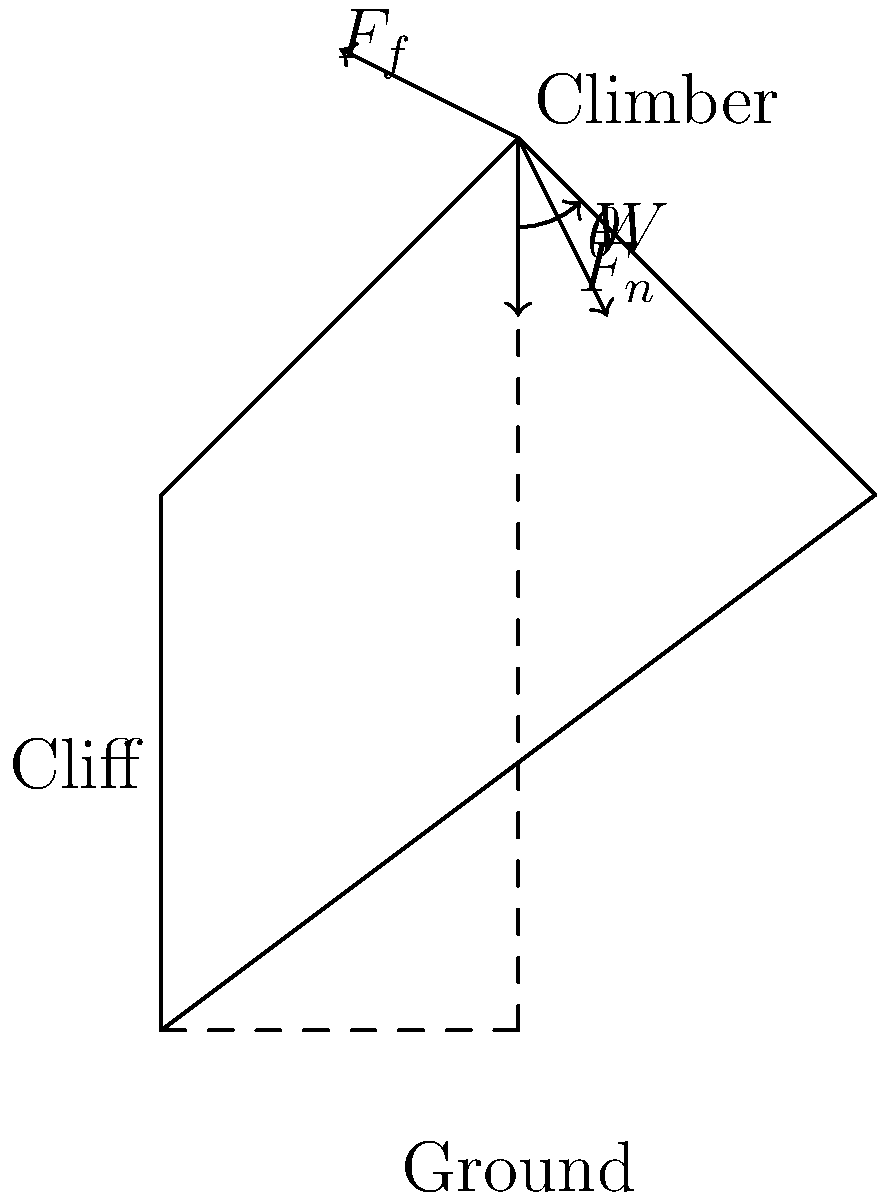A rock climber weighing 70 kg is scaling an overhanging cliff at an angle of $45^\circ$ to the horizontal. If the coefficient of static friction between the climber's hands and the rock face is 0.8, what is the minimum normal force the climber must exert to maintain their position? Let's approach this step-by-step:

1) First, we need to identify the forces acting on the climber:
   - Weight ($W$) acting downward
   - Normal force ($F_n$) perpendicular to the cliff surface
   - Friction force ($F_f$) parallel to the cliff surface

2) The weight of the climber is:
   $W = mg = 70 \text{ kg} \times 9.8 \text{ m/s}^2 = 686 \text{ N}$

3) We can resolve the weight into components parallel and perpendicular to the cliff:
   - Parallel component: $W_\parallel = W \sin 45^\circ = 686 \times \frac{\sqrt{2}}{2} = 485 \text{ N}$
   - Perpendicular component: $W_\perp = W \cos 45^\circ = 686 \times \frac{\sqrt{2}}{2} = 485 \text{ N}$

4) For the climber to maintain position, the friction force must equal the parallel component of weight:
   $F_f = W_\parallel = 485 \text{ N}$

5) We know that the maximum static friction is given by $F_f = \mu F_n$, where $\mu$ is the coefficient of static friction. Therefore:
   $485 = 0.8 F_n$

6) Solving for $F_n$:
   $F_n = \frac{485}{0.8} = 606.25 \text{ N}$

This is the minimum normal force required to prevent sliding.
Answer: 606.25 N 